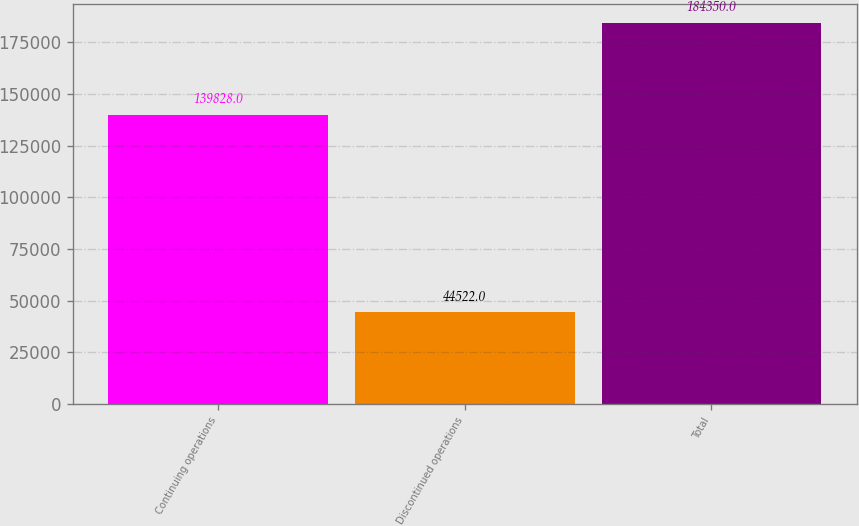Convert chart. <chart><loc_0><loc_0><loc_500><loc_500><bar_chart><fcel>Continuing operations<fcel>Discontinued operations<fcel>Total<nl><fcel>139828<fcel>44522<fcel>184350<nl></chart> 